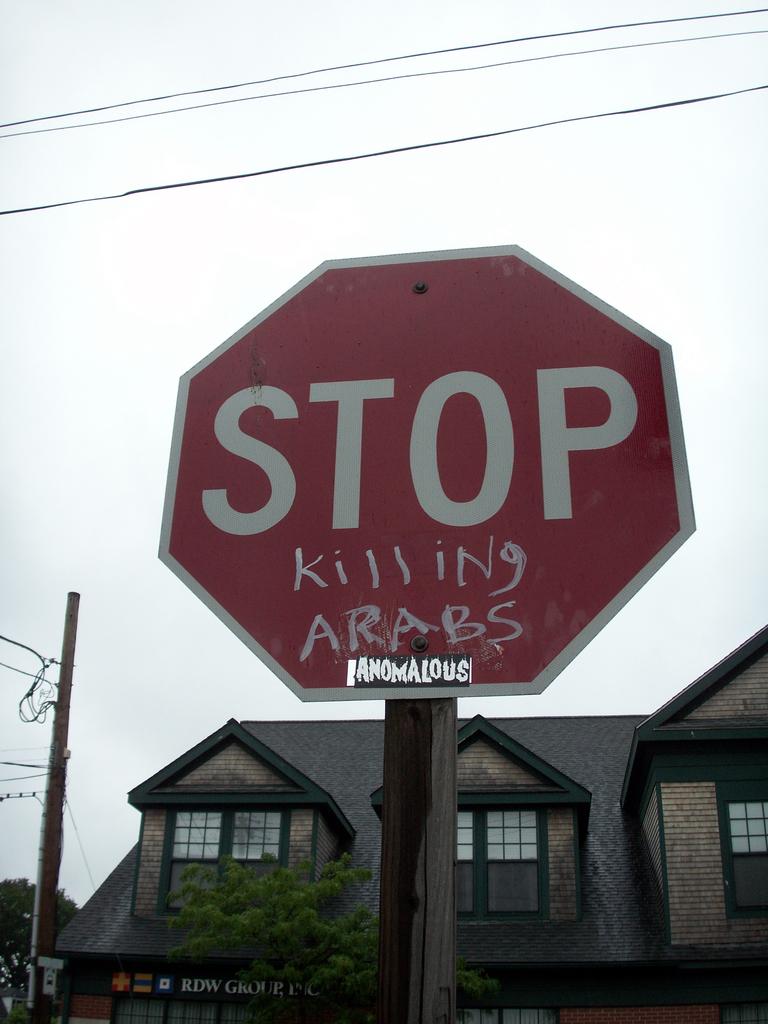What kind of sign is this?
Your answer should be very brief. Stop. What racial slur is written below stop on the sign?
Keep it short and to the point. Arabs. 